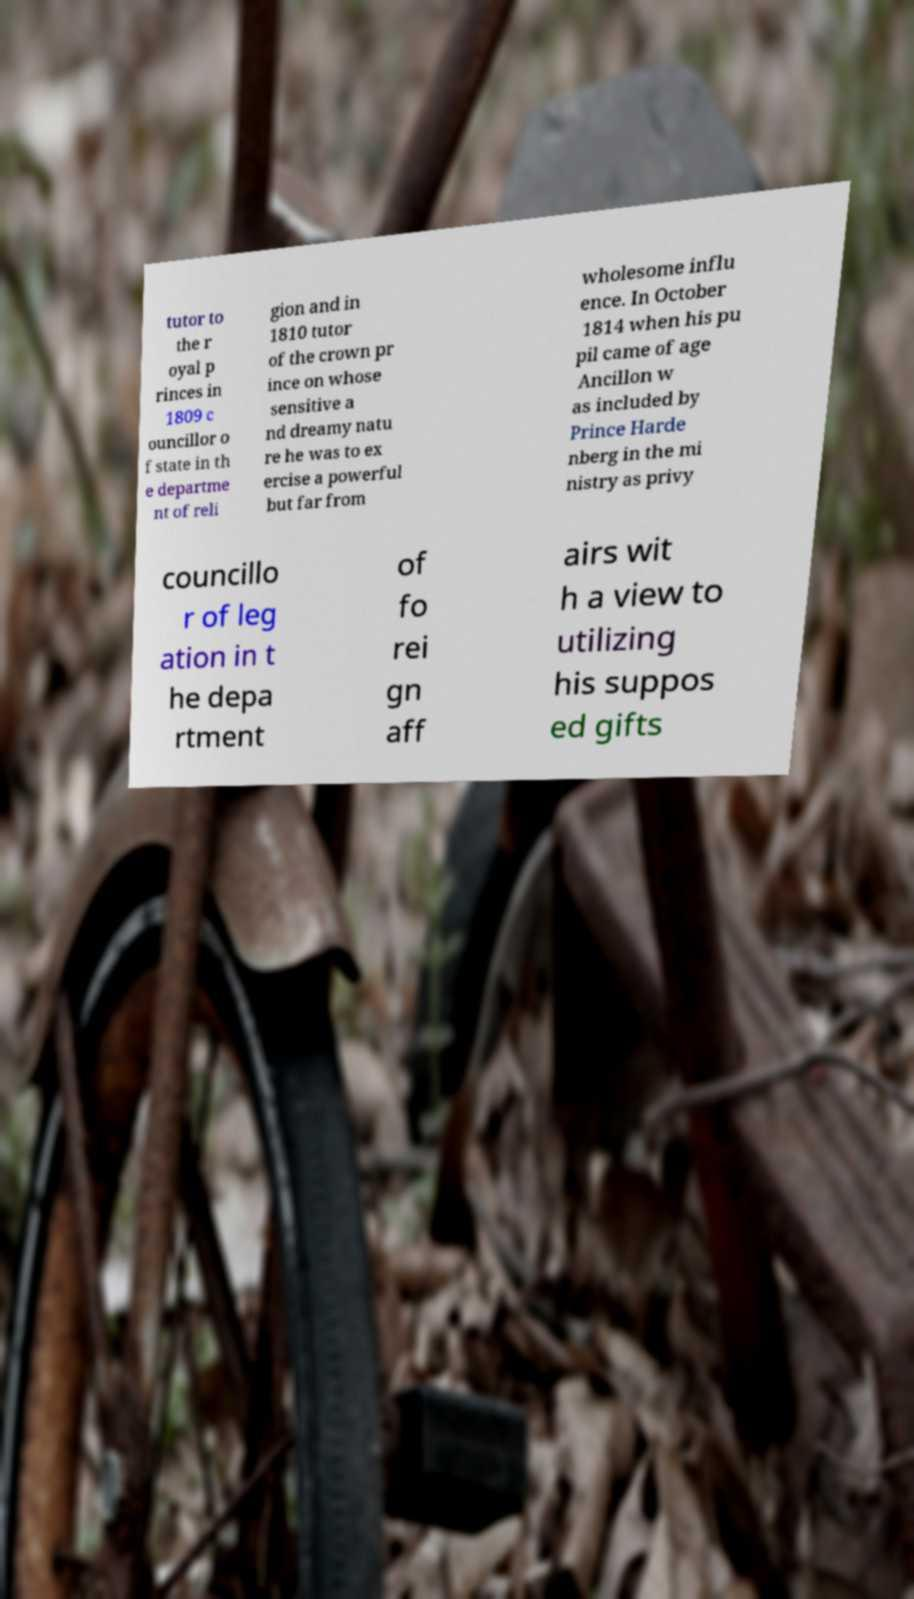Could you assist in decoding the text presented in this image and type it out clearly? tutor to the r oyal p rinces in 1809 c ouncillor o f state in th e departme nt of reli gion and in 1810 tutor of the crown pr ince on whose sensitive a nd dreamy natu re he was to ex ercise a powerful but far from wholesome influ ence. In October 1814 when his pu pil came of age Ancillon w as included by Prince Harde nberg in the mi nistry as privy councillo r of leg ation in t he depa rtment of fo rei gn aff airs wit h a view to utilizing his suppos ed gifts 